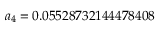Convert formula to latex. <formula><loc_0><loc_0><loc_500><loc_500>a _ { 4 } = 0 . 0 5 5 2 8 7 3 2 1 4 4 4 7 8 4 0 8</formula> 